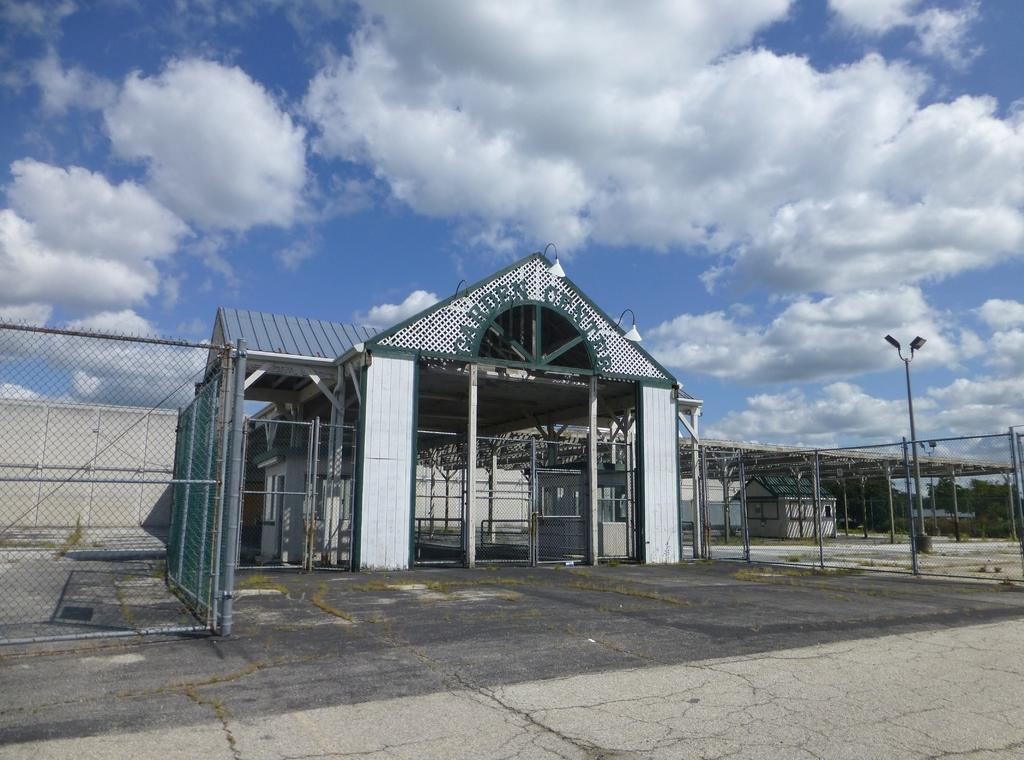What is written at the top of the building in the image? There is a building with a name at the top in the image. What type of structure is located under a shed in the image? There is a small house under a shed in the image. What can be seen surrounding the area in the image? There are fences in the image. How many lights are on the pole in the image? There are two lights on a pole in the image. What type of vegetation is present in the image? There are trees in the image. What is visible in the sky in the image? There are clouds in the sky in the image. What type of feast is being prepared under the shed in the image? There is no indication of a feast being prepared in the image; it features a small house under a shed. What type of ice can be seen melting on the roof of the building in the image? There is no ice present on the roof of the building in the image. 